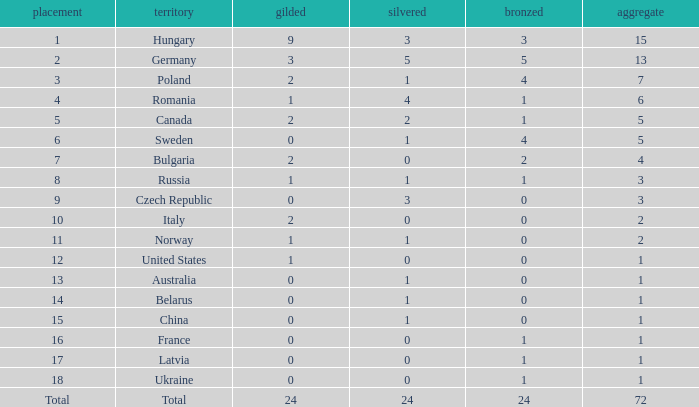What nation has 0 as the silver, 1 as the bronze, with 18 as the rank? Ukraine. 